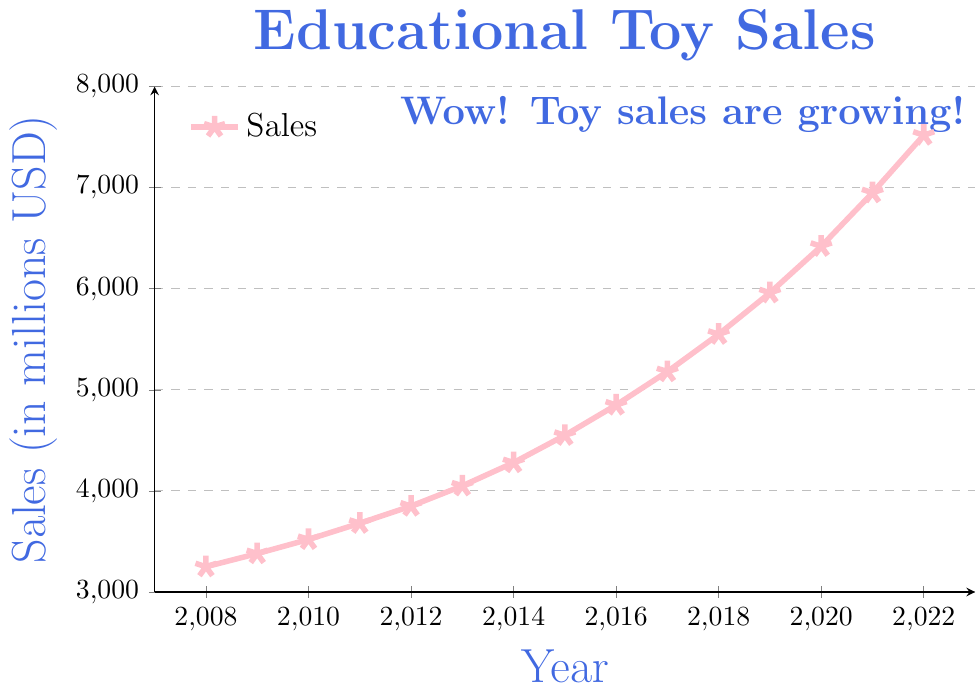What is the sales figure for the year 2010? Referring to the plotted data point for the year 2010, the sales figure is indicated by a point on the graph which corresponds to 3520 million USD on the y-axis.
Answer: 3520 By how much did the sales increase from 2008 to 2022? To find the increase, subtract the sales figure of 2008 from the sales figure of 2022: 7520 - 3250. So, the sales increased by 4270 million USD.
Answer: 4270 In which year did the sales reach 6420 million USD? Look at the data points on the graph: the sales figure of 6420 million USD corresponds to the year 2020.
Answer: 2020 Which year had higher sales: 2015 or 2016? By comparing the y-values of the data points for 2015 and 2016, 2016 had a higher sales figure (4850 million USD) than 2015 (4550 million USD).
Answer: 2016 What is the average sales figure from 2010 to 2012? Sum the sales figures of the years 2010, 2011, and 2012: 3520 + 3680 + 3850 = 11050. Then divide by the number of years (3): 11050 / 3 ≈ 3683.33 million USD.
Answer: 3683.33 What is the trend of the sales figure from 2008 to 2022? The overall trend can be observed by looking at the shape of the line, which shows a steady increase from 3250 million USD in 2008 to 7520 million USD in 2022.
Answer: Increasing Was there any year where sales were less than the previous year? By examining the line chart, there are no years where the sales decrease; every year shows an increase.
Answer: No Between which two consecutive years was the largest increase in sales observed? Comparing the increases year by year, the largest increase from 2021 (6950 million USD) to 2022 (7520 million USD) was 570 million USD.
Answer: 2021 to 2022 What is the median sales figure for the period 2008-2022? To find the median, we list all the sales figures in ascending order and find the middle value. The data has 15 values, so the median is the 8th value: 4550 million USD for the year 2015.
Answer: 4550 